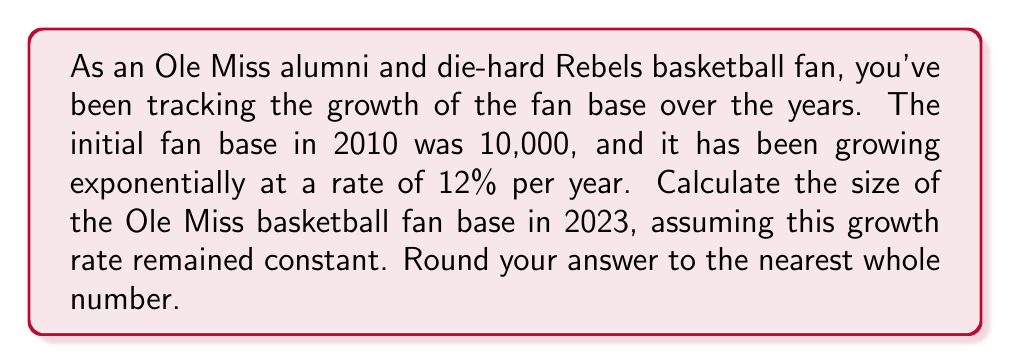Could you help me with this problem? To solve this problem, we'll use the exponential growth formula:

$$A = P(1 + r)^t$$

Where:
$A$ = Final amount
$P$ = Initial principal amount
$r$ = Annual growth rate (as a decimal)
$t$ = Time period (in years)

Given:
$P = 10,000$ (initial fan base in 2010)
$r = 0.12$ (12% growth rate)
$t = 13$ (years from 2010 to 2023)

Let's plug these values into the formula:

$$A = 10,000(1 + 0.12)^{13}$$

Now, let's calculate step by step:

1) First, calculate $(1 + 0.12)$:
   $1 + 0.12 = 1.12$

2) Now, we have:
   $$A = 10,000(1.12)^{13}$$

3) Calculate $(1.12)^{13}$:
   $(1.12)^{13} \approx 4.0994$

4) Finally, multiply:
   $$A = 10,000 * 4.0994 = 40,994$$

5) Rounding to the nearest whole number:
   $$A \approx 40,994$$
Answer: The size of the Ole Miss basketball fan base in 2023 would be approximately 40,994 fans. 